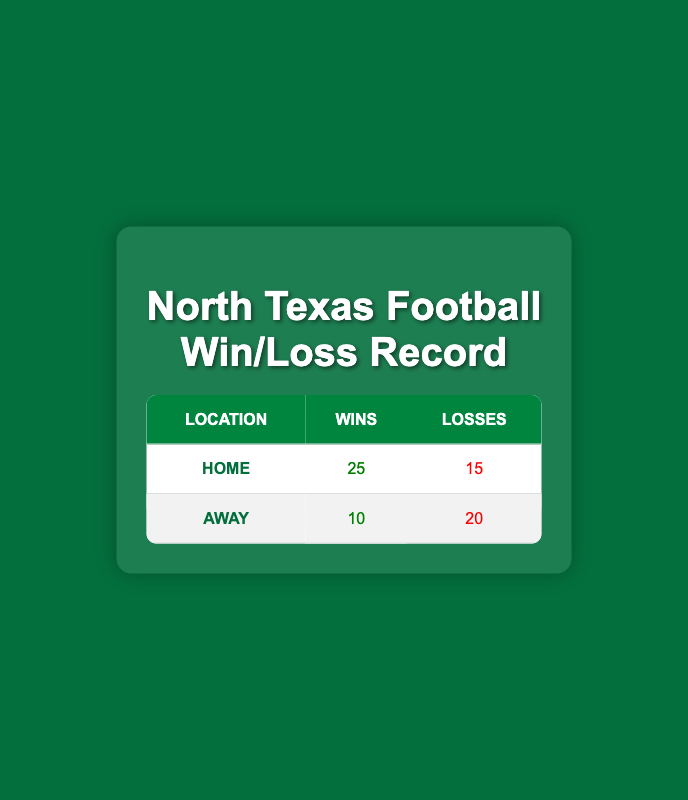What is the total number of wins for the North Texas football team? The total number of wins is calculated by adding wins from both home and away games. Home wins are 25 and away wins are 10, so the total is 25 + 10 = 35.
Answer: 35 What is the total number of losses for the North Texas football team? To find the total losses, sum the losses from both home and away games. Home losses are 15 and away losses are 20, so the total is 15 + 20 = 35.
Answer: 35 Is it true that North Texas football team has more wins at home than away? Looking at the wins, home wins are 25 and away wins are 10. Since 25 is greater than 10, it is true that they have more wins at home.
Answer: Yes What is the difference in the number of losses when comparing home and away games? The difference in losses is calculated by subtracting away losses from home losses. Home losses are 15 and away losses are 20, so the difference is 20 - 15 = 5.
Answer: 5 What percentage of the total games played at home resulted in wins for the North Texas football team? First, we calculate the total games played at home, which is the sum of home wins and losses: 25 + 15 = 40. Then, to find the percentage of wins, we use the formula (wins/home games) x 100. Therefore, (25/40) x 100 = 62.5%.
Answer: 62.5% How many more losses does the North Texas football team have in away games compared to home games? The number of losses at home is 15 and the number of losses away is 20. To find how many more the away losses are, subtract home losses from away losses: 20 - 15 = 5.
Answer: 5 What is the ratio of wins to losses at home for the North Texas football team? To find the ratio of wins to losses at home, we compare home wins (25) with home losses (15). The ratio is 25:15, which can also be simplified to 5:3.
Answer: 5:3 Is the win rate away from home higher than the win rate at home? First, we need the win rates. The win rate at home is 25/(25+15) = 25/40 = 0.625 or 62.5%. The win rate away is 10/(10+20) = 10/30 = 0.333 or 33.3%. Since 62.5% is higher than 33.3%, it is false that the away win rate is higher.
Answer: No What is the average number of wins per game played at home? We first determine the total number of games played at home, which is 25 wins plus 15 losses, giving a total of 40 games. The average number of wins per game at home is calculated as total wins divided by total games: 25/40 = 0.625, or 62.5%.
Answer: 62.5% 